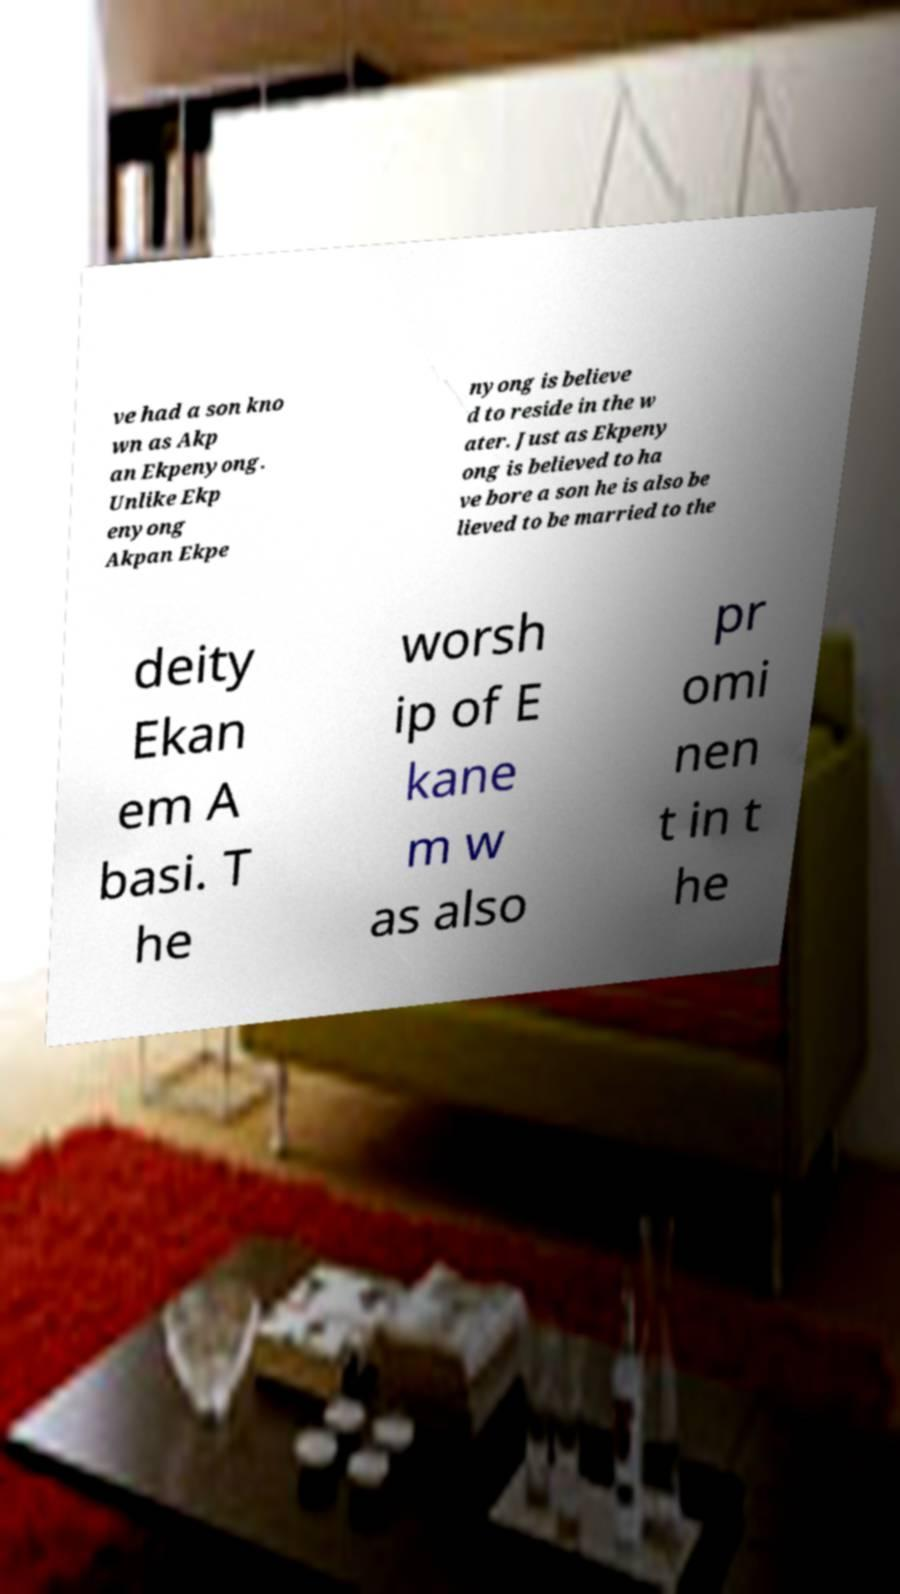Please identify and transcribe the text found in this image. ve had a son kno wn as Akp an Ekpenyong. Unlike Ekp enyong Akpan Ekpe nyong is believe d to reside in the w ater. Just as Ekpeny ong is believed to ha ve bore a son he is also be lieved to be married to the deity Ekan em A basi. T he worsh ip of E kane m w as also pr omi nen t in t he 